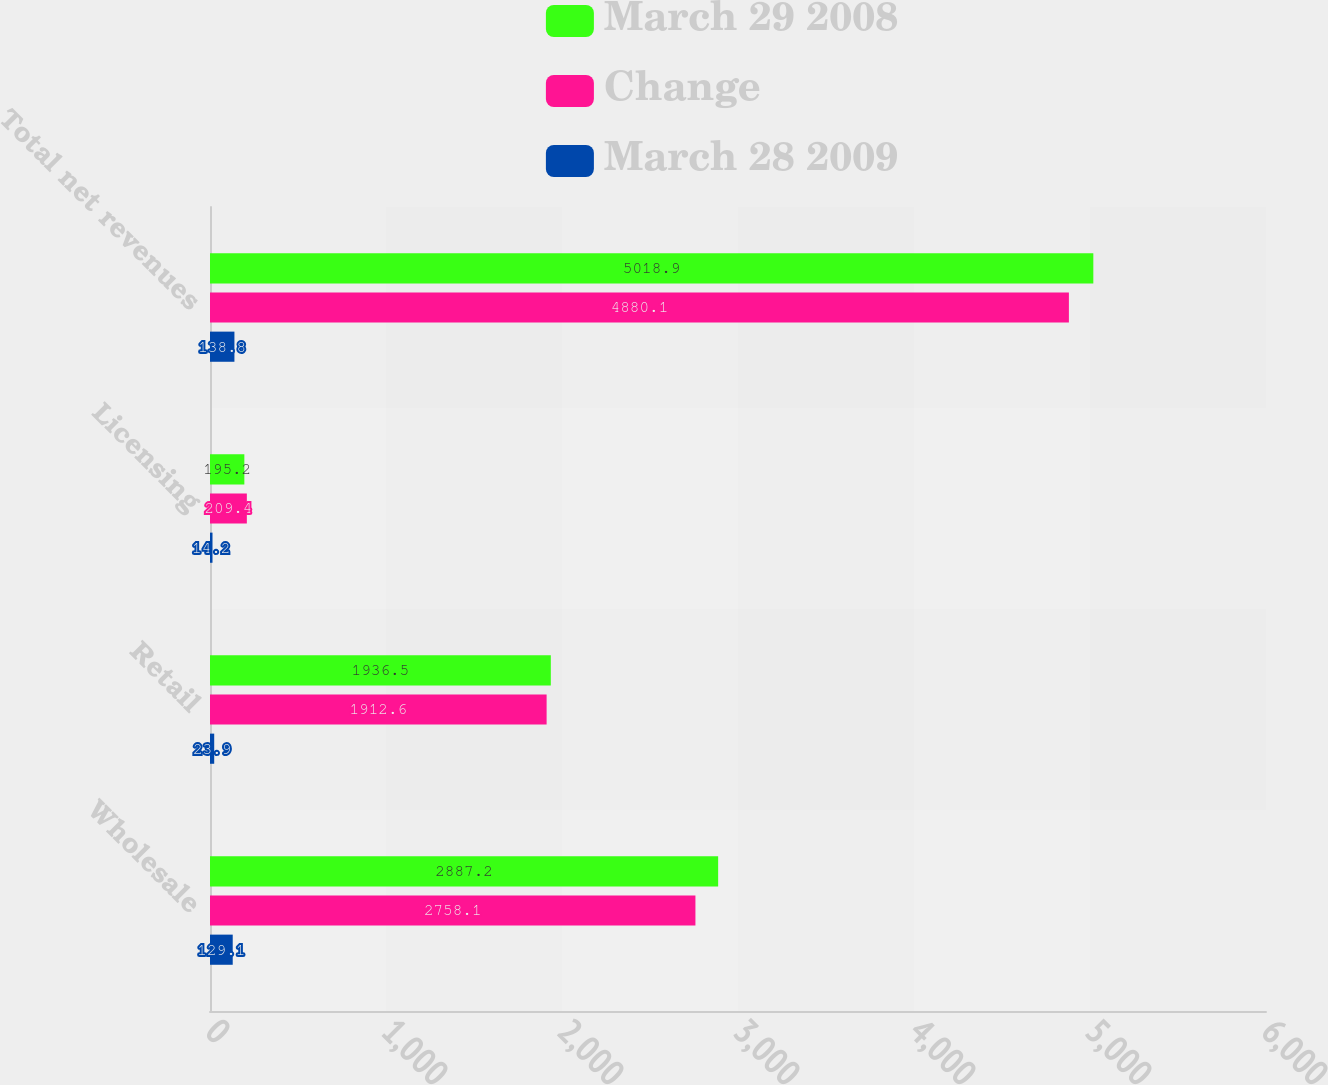<chart> <loc_0><loc_0><loc_500><loc_500><stacked_bar_chart><ecel><fcel>Wholesale<fcel>Retail<fcel>Licensing<fcel>Total net revenues<nl><fcel>March 29 2008<fcel>2887.2<fcel>1936.5<fcel>195.2<fcel>5018.9<nl><fcel>Change<fcel>2758.1<fcel>1912.6<fcel>209.4<fcel>4880.1<nl><fcel>March 28 2009<fcel>129.1<fcel>23.9<fcel>14.2<fcel>138.8<nl></chart> 